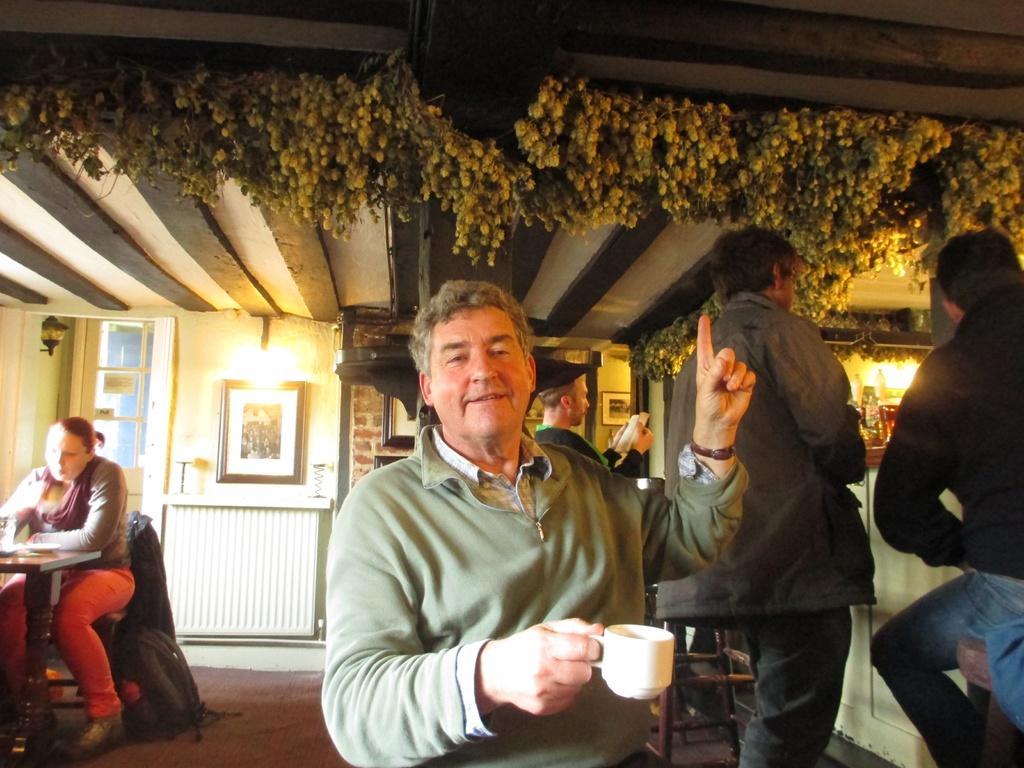Can you describe this image briefly? In this picture we can see a man holding a cup with his hand and smiling and in the background we can see some people, frames on the wall, lights. 